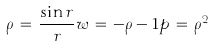<formula> <loc_0><loc_0><loc_500><loc_500>\rho \, = \, \frac { \sin r } { r } w \, = \, - \rho - 1 p \, = \, \rho ^ { 2 }</formula> 